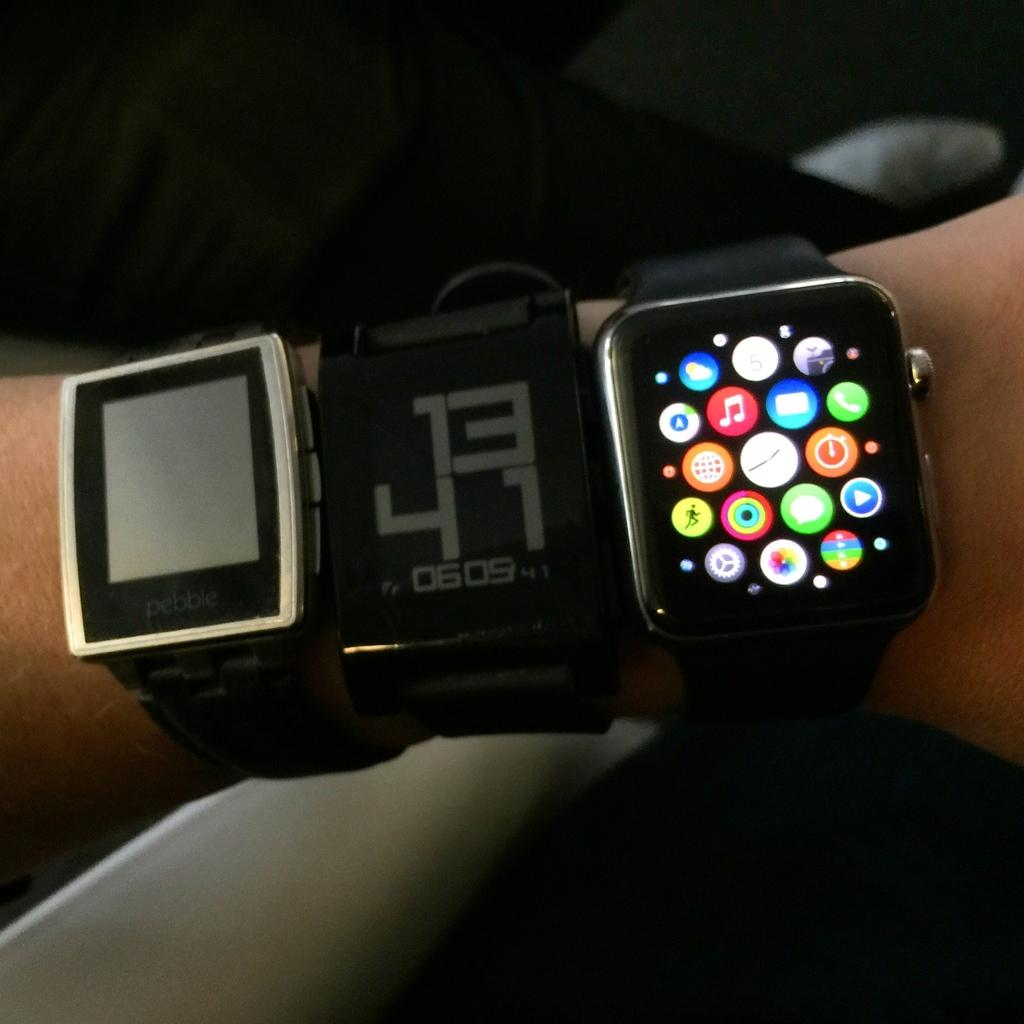<image>
Render a clear and concise summary of the photo. A person is wearing 3 smart watches, one made by Pebble. 